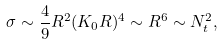Convert formula to latex. <formula><loc_0><loc_0><loc_500><loc_500>\sigma \sim \frac { 4 } { 9 } R ^ { 2 } ( K _ { 0 } R ) ^ { 4 } \sim R ^ { 6 } \sim N _ { t } ^ { 2 } ,</formula> 